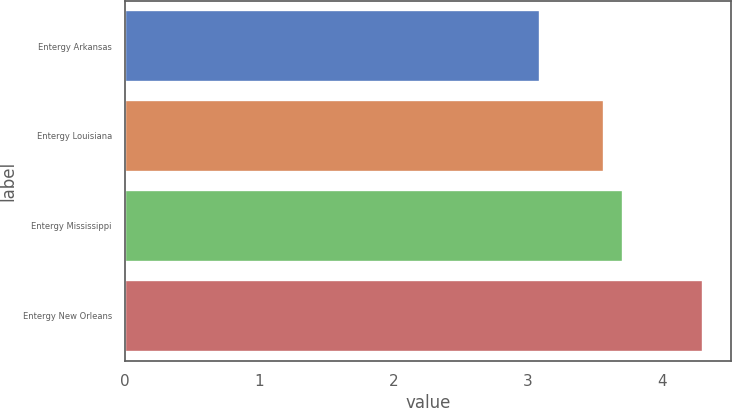Convert chart. <chart><loc_0><loc_0><loc_500><loc_500><bar_chart><fcel>Entergy Arkansas<fcel>Entergy Louisiana<fcel>Entergy Mississippi<fcel>Entergy New Orleans<nl><fcel>3.09<fcel>3.57<fcel>3.71<fcel>4.3<nl></chart> 